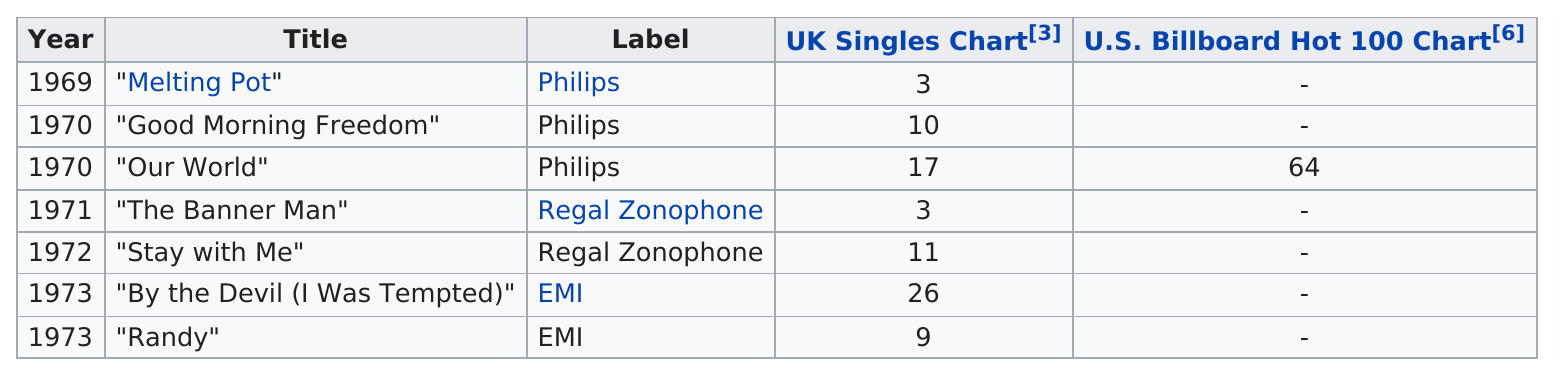Specify some key components in this picture. The total number of years for singles by Philips label is three. The next single released after "Melting Pot" was "Good Morning Freedom." The single titled "Melting Pot" had the most success on the UK Singles Chart. The single "Melting Pot" had the highest chart position in the UK Singles Chart, while "The Banner Man" also had a notable position. The first single to be released under the Regal Zonophone label was "The Banner Man. 